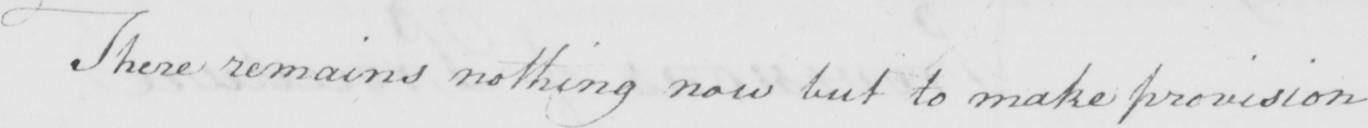What text is written in this handwritten line? There remains nothing now but to make provision 